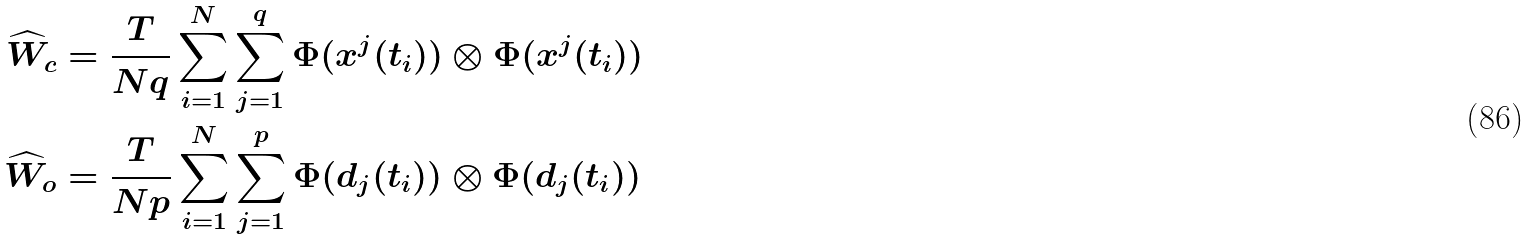<formula> <loc_0><loc_0><loc_500><loc_500>\widehat { W } _ { c } & = \frac { T } { N q } \sum _ { i = 1 } ^ { N } \sum _ { j = 1 } ^ { q } \Phi ( x ^ { j } ( t _ { i } ) ) \otimes \Phi ( x ^ { j } ( t _ { i } ) ) \\ \widehat { W } _ { o } & = \frac { T } { N p } \sum _ { i = 1 } ^ { N } \sum _ { j = 1 } ^ { p } \Phi ( d _ { j } ( t _ { i } ) ) \otimes \Phi ( d _ { j } ( t _ { i } ) )</formula> 